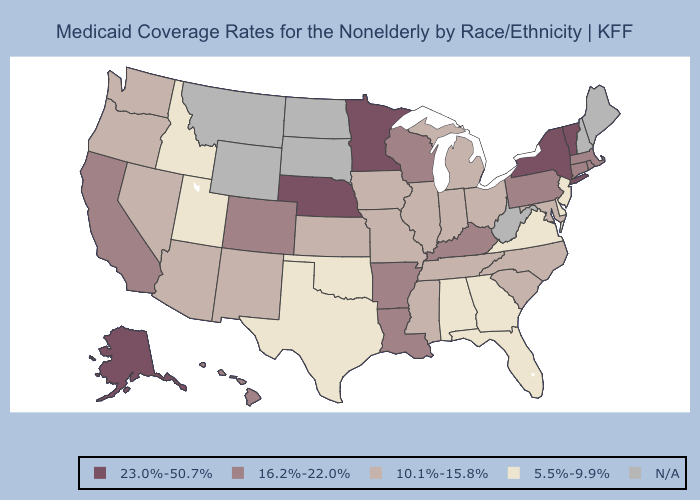What is the highest value in the Northeast ?
Be succinct. 23.0%-50.7%. What is the highest value in the West ?
Short answer required. 23.0%-50.7%. Does Oregon have the highest value in the USA?
Write a very short answer. No. What is the highest value in the Northeast ?
Keep it brief. 23.0%-50.7%. What is the value of Hawaii?
Be succinct. 16.2%-22.0%. What is the highest value in the Northeast ?
Write a very short answer. 23.0%-50.7%. Name the states that have a value in the range 16.2%-22.0%?
Give a very brief answer. Arkansas, California, Colorado, Connecticut, Hawaii, Kentucky, Louisiana, Massachusetts, Pennsylvania, Rhode Island, Wisconsin. How many symbols are there in the legend?
Short answer required. 5. Does Alaska have the highest value in the USA?
Give a very brief answer. Yes. Name the states that have a value in the range 23.0%-50.7%?
Concise answer only. Alaska, Minnesota, Nebraska, New York, Vermont. What is the value of Texas?
Short answer required. 5.5%-9.9%. Does Oregon have the highest value in the USA?
Be succinct. No. Among the states that border Massachusetts , which have the lowest value?
Write a very short answer. Connecticut, Rhode Island. 